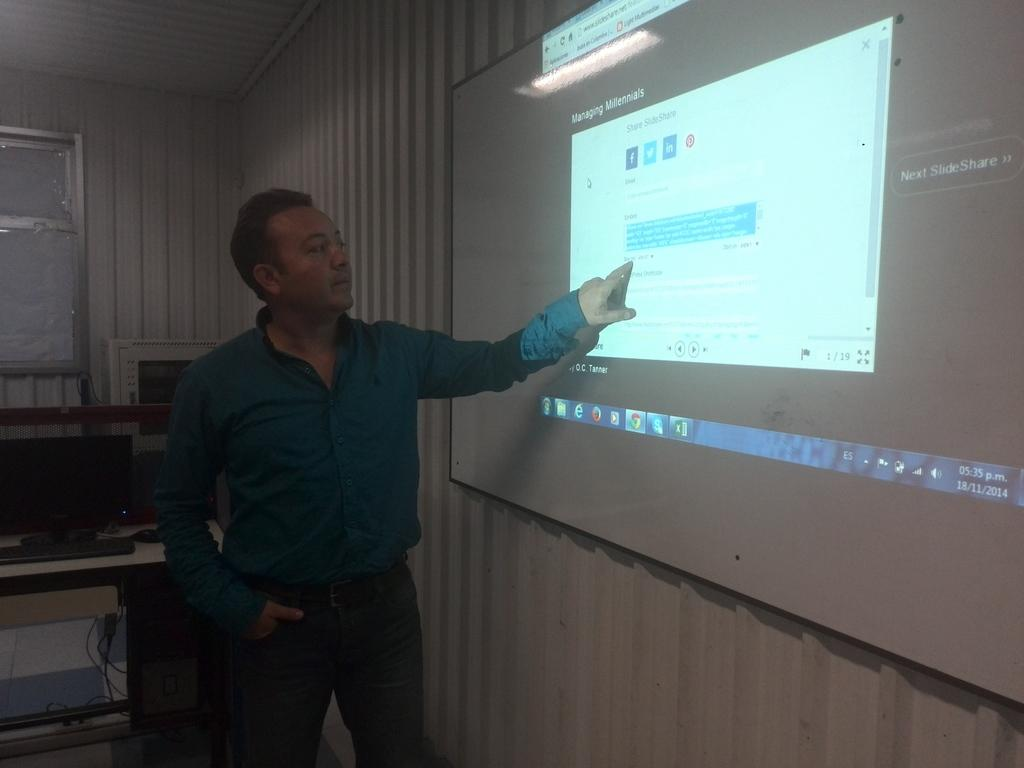<image>
Describe the image concisely. A man pointing at a projected image with Facebook on it 